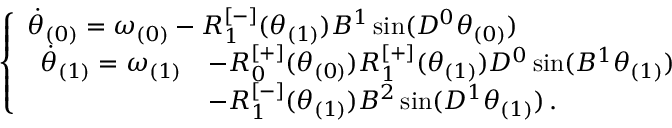Convert formula to latex. <formula><loc_0><loc_0><loc_500><loc_500>\begin{array} { r } { \left \{ \begin{array} { l l } { \ D o t { \theta } _ { ( 0 ) } = \omega _ { ( 0 ) } - R _ { 1 } ^ { [ - ] } ( \theta _ { ( 1 ) } ) B ^ { 1 } \sin ( D ^ { 0 } \theta _ { ( 0 ) } ) } \\ { \begin{array} { r l } { \ D o t { \theta } _ { ( 1 ) } = \omega _ { ( 1 ) } } & { - R _ { 0 } ^ { [ + ] } ( \theta _ { ( 0 ) } ) R _ { 1 } ^ { [ + ] } ( \theta _ { ( 1 ) } ) D ^ { 0 } \sin ( B ^ { 1 } \theta _ { ( 1 ) } ) } \\ & { - R _ { 1 } ^ { [ - ] } ( \theta _ { ( 1 ) } ) B ^ { 2 } \sin ( D ^ { 1 } \theta _ { ( 1 ) } ) \, . } \end{array} } \end{array} } \end{array}</formula> 